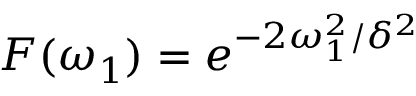<formula> <loc_0><loc_0><loc_500><loc_500>F ( \omega _ { 1 } ) = e ^ { - 2 \omega _ { 1 } ^ { 2 } / \delta ^ { 2 } }</formula> 